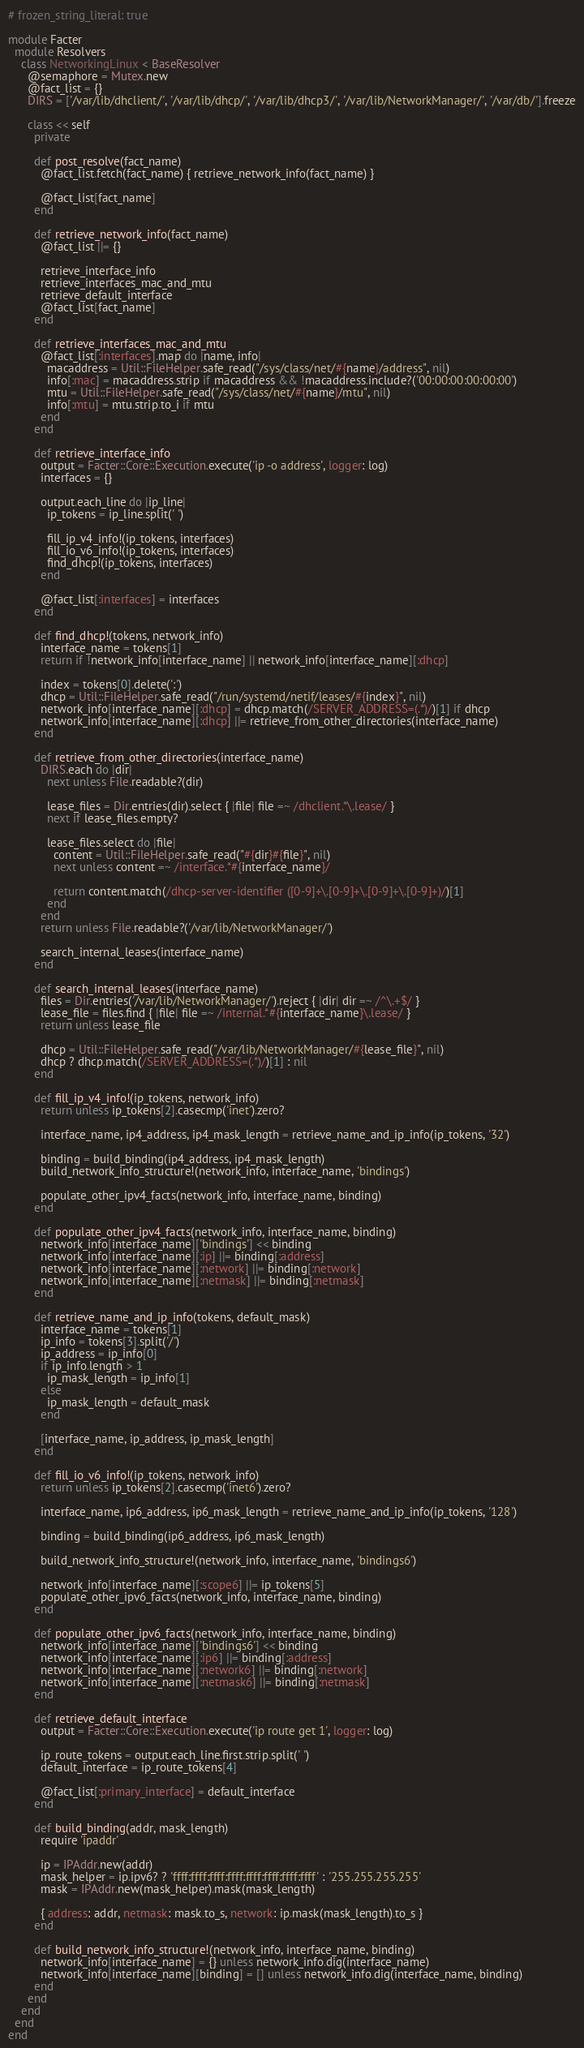Convert code to text. <code><loc_0><loc_0><loc_500><loc_500><_Ruby_># frozen_string_literal: true

module Facter
  module Resolvers
    class NetworkingLinux < BaseResolver
      @semaphore = Mutex.new
      @fact_list = {}
      DIRS = ['/var/lib/dhclient/', '/var/lib/dhcp/', '/var/lib/dhcp3/', '/var/lib/NetworkManager/', '/var/db/'].freeze

      class << self
        private

        def post_resolve(fact_name)
          @fact_list.fetch(fact_name) { retrieve_network_info(fact_name) }

          @fact_list[fact_name]
        end

        def retrieve_network_info(fact_name)
          @fact_list ||= {}

          retrieve_interface_info
          retrieve_interfaces_mac_and_mtu
          retrieve_default_interface
          @fact_list[fact_name]
        end

        def retrieve_interfaces_mac_and_mtu
          @fact_list[:interfaces].map do |name, info|
            macaddress = Util::FileHelper.safe_read("/sys/class/net/#{name}/address", nil)
            info[:mac] = macaddress.strip if macaddress && !macaddress.include?('00:00:00:00:00:00')
            mtu = Util::FileHelper.safe_read("/sys/class/net/#{name}/mtu", nil)
            info[:mtu] = mtu.strip.to_i if mtu
          end
        end

        def retrieve_interface_info
          output = Facter::Core::Execution.execute('ip -o address', logger: log)
          interfaces = {}

          output.each_line do |ip_line|
            ip_tokens = ip_line.split(' ')

            fill_ip_v4_info!(ip_tokens, interfaces)
            fill_io_v6_info!(ip_tokens, interfaces)
            find_dhcp!(ip_tokens, interfaces)
          end

          @fact_list[:interfaces] = interfaces
        end

        def find_dhcp!(tokens, network_info)
          interface_name = tokens[1]
          return if !network_info[interface_name] || network_info[interface_name][:dhcp]

          index = tokens[0].delete(':')
          dhcp = Util::FileHelper.safe_read("/run/systemd/netif/leases/#{index}", nil)
          network_info[interface_name][:dhcp] = dhcp.match(/SERVER_ADDRESS=(.*)/)[1] if dhcp
          network_info[interface_name][:dhcp] ||= retrieve_from_other_directories(interface_name)
        end

        def retrieve_from_other_directories(interface_name)
          DIRS.each do |dir|
            next unless File.readable?(dir)

            lease_files = Dir.entries(dir).select { |file| file =~ /dhclient.*\.lease/ }
            next if lease_files.empty?

            lease_files.select do |file|
              content = Util::FileHelper.safe_read("#{dir}#{file}", nil)
              next unless content =~ /interface.*#{interface_name}/

              return content.match(/dhcp-server-identifier ([0-9]+\.[0-9]+\.[0-9]+\.[0-9]+)/)[1]
            end
          end
          return unless File.readable?('/var/lib/NetworkManager/')

          search_internal_leases(interface_name)
        end

        def search_internal_leases(interface_name)
          files = Dir.entries('/var/lib/NetworkManager/').reject { |dir| dir =~ /^\.+$/ }
          lease_file = files.find { |file| file =~ /internal.*#{interface_name}\.lease/ }
          return unless lease_file

          dhcp = Util::FileHelper.safe_read("/var/lib/NetworkManager/#{lease_file}", nil)
          dhcp ? dhcp.match(/SERVER_ADDRESS=(.*)/)[1] : nil
        end

        def fill_ip_v4_info!(ip_tokens, network_info)
          return unless ip_tokens[2].casecmp('inet').zero?

          interface_name, ip4_address, ip4_mask_length = retrieve_name_and_ip_info(ip_tokens, '32')

          binding = build_binding(ip4_address, ip4_mask_length)
          build_network_info_structure!(network_info, interface_name, 'bindings')

          populate_other_ipv4_facts(network_info, interface_name, binding)
        end

        def populate_other_ipv4_facts(network_info, interface_name, binding)
          network_info[interface_name]['bindings'] << binding
          network_info[interface_name][:ip] ||= binding[:address]
          network_info[interface_name][:network] ||= binding[:network]
          network_info[interface_name][:netmask] ||= binding[:netmask]
        end

        def retrieve_name_and_ip_info(tokens, default_mask)
          interface_name = tokens[1]
          ip_info = tokens[3].split('/')
          ip_address = ip_info[0]
          if ip_info.length > 1
            ip_mask_length = ip_info[1]
          else
            ip_mask_length = default_mask
          end

          [interface_name, ip_address, ip_mask_length]
        end

        def fill_io_v6_info!(ip_tokens, network_info)
          return unless ip_tokens[2].casecmp('inet6').zero?

          interface_name, ip6_address, ip6_mask_length = retrieve_name_and_ip_info(ip_tokens, '128')

          binding = build_binding(ip6_address, ip6_mask_length)

          build_network_info_structure!(network_info, interface_name, 'bindings6')

          network_info[interface_name][:scope6] ||= ip_tokens[5]
          populate_other_ipv6_facts(network_info, interface_name, binding)
        end

        def populate_other_ipv6_facts(network_info, interface_name, binding)
          network_info[interface_name]['bindings6'] << binding
          network_info[interface_name][:ip6] ||= binding[:address]
          network_info[interface_name][:network6] ||= binding[:network]
          network_info[interface_name][:netmask6] ||= binding[:netmask]
        end

        def retrieve_default_interface
          output = Facter::Core::Execution.execute('ip route get 1', logger: log)

          ip_route_tokens = output.each_line.first.strip.split(' ')
          default_interface = ip_route_tokens[4]

          @fact_list[:primary_interface] = default_interface
        end

        def build_binding(addr, mask_length)
          require 'ipaddr'

          ip = IPAddr.new(addr)
          mask_helper = ip.ipv6? ? 'ffff:ffff:ffff:ffff:ffff:ffff:ffff:ffff' : '255.255.255.255'
          mask = IPAddr.new(mask_helper).mask(mask_length)

          { address: addr, netmask: mask.to_s, network: ip.mask(mask_length).to_s }
        end

        def build_network_info_structure!(network_info, interface_name, binding)
          network_info[interface_name] = {} unless network_info.dig(interface_name)
          network_info[interface_name][binding] = [] unless network_info.dig(interface_name, binding)
        end
      end
    end
  end
end
</code> 